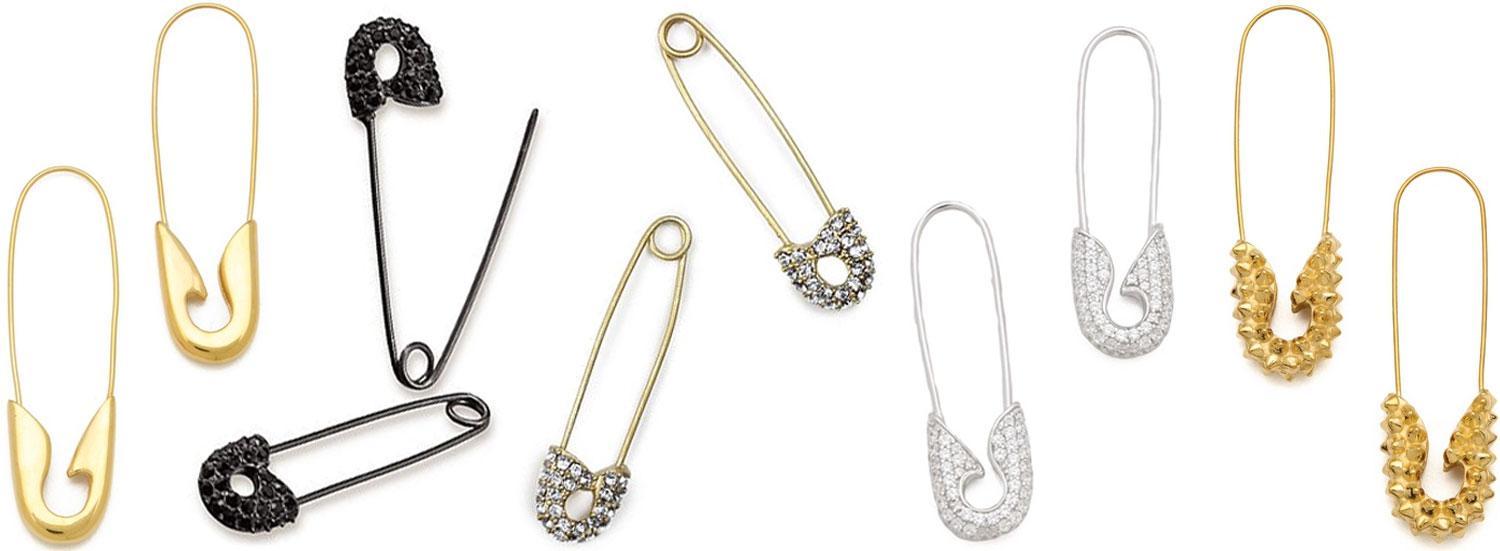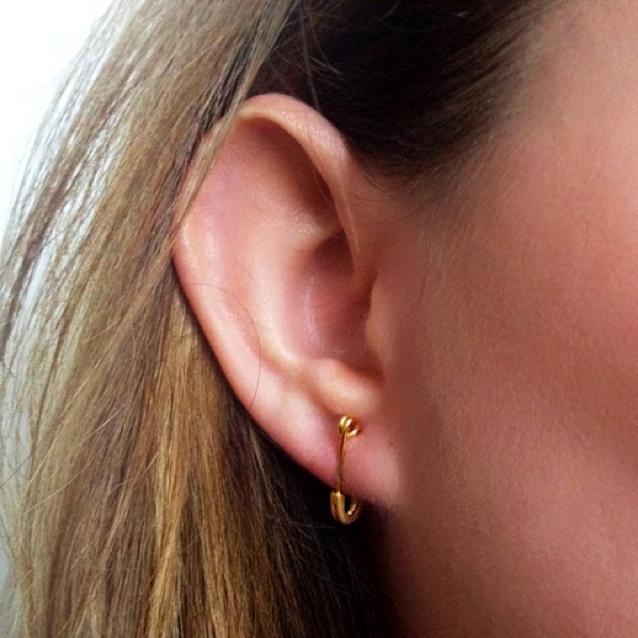The first image is the image on the left, the second image is the image on the right. For the images shown, is this caption "One of the images shows a safety pin that is in a location other than a woman's ear." true? Answer yes or no. Yes. The first image is the image on the left, the second image is the image on the right. Assess this claim about the two images: "There are two women who are both wearing earrings.". Correct or not? Answer yes or no. No. 